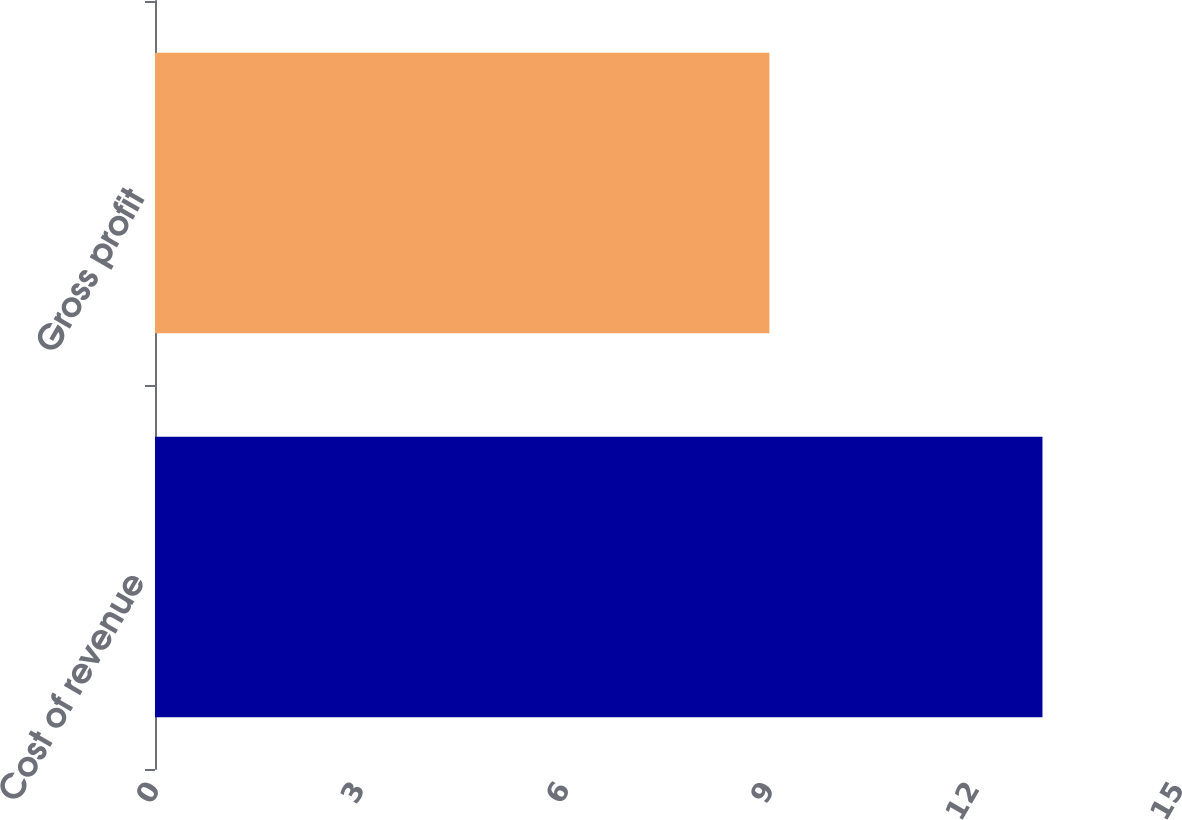Convert chart. <chart><loc_0><loc_0><loc_500><loc_500><bar_chart><fcel>Cost of revenue<fcel>Gross profit<nl><fcel>13<fcel>9<nl></chart> 